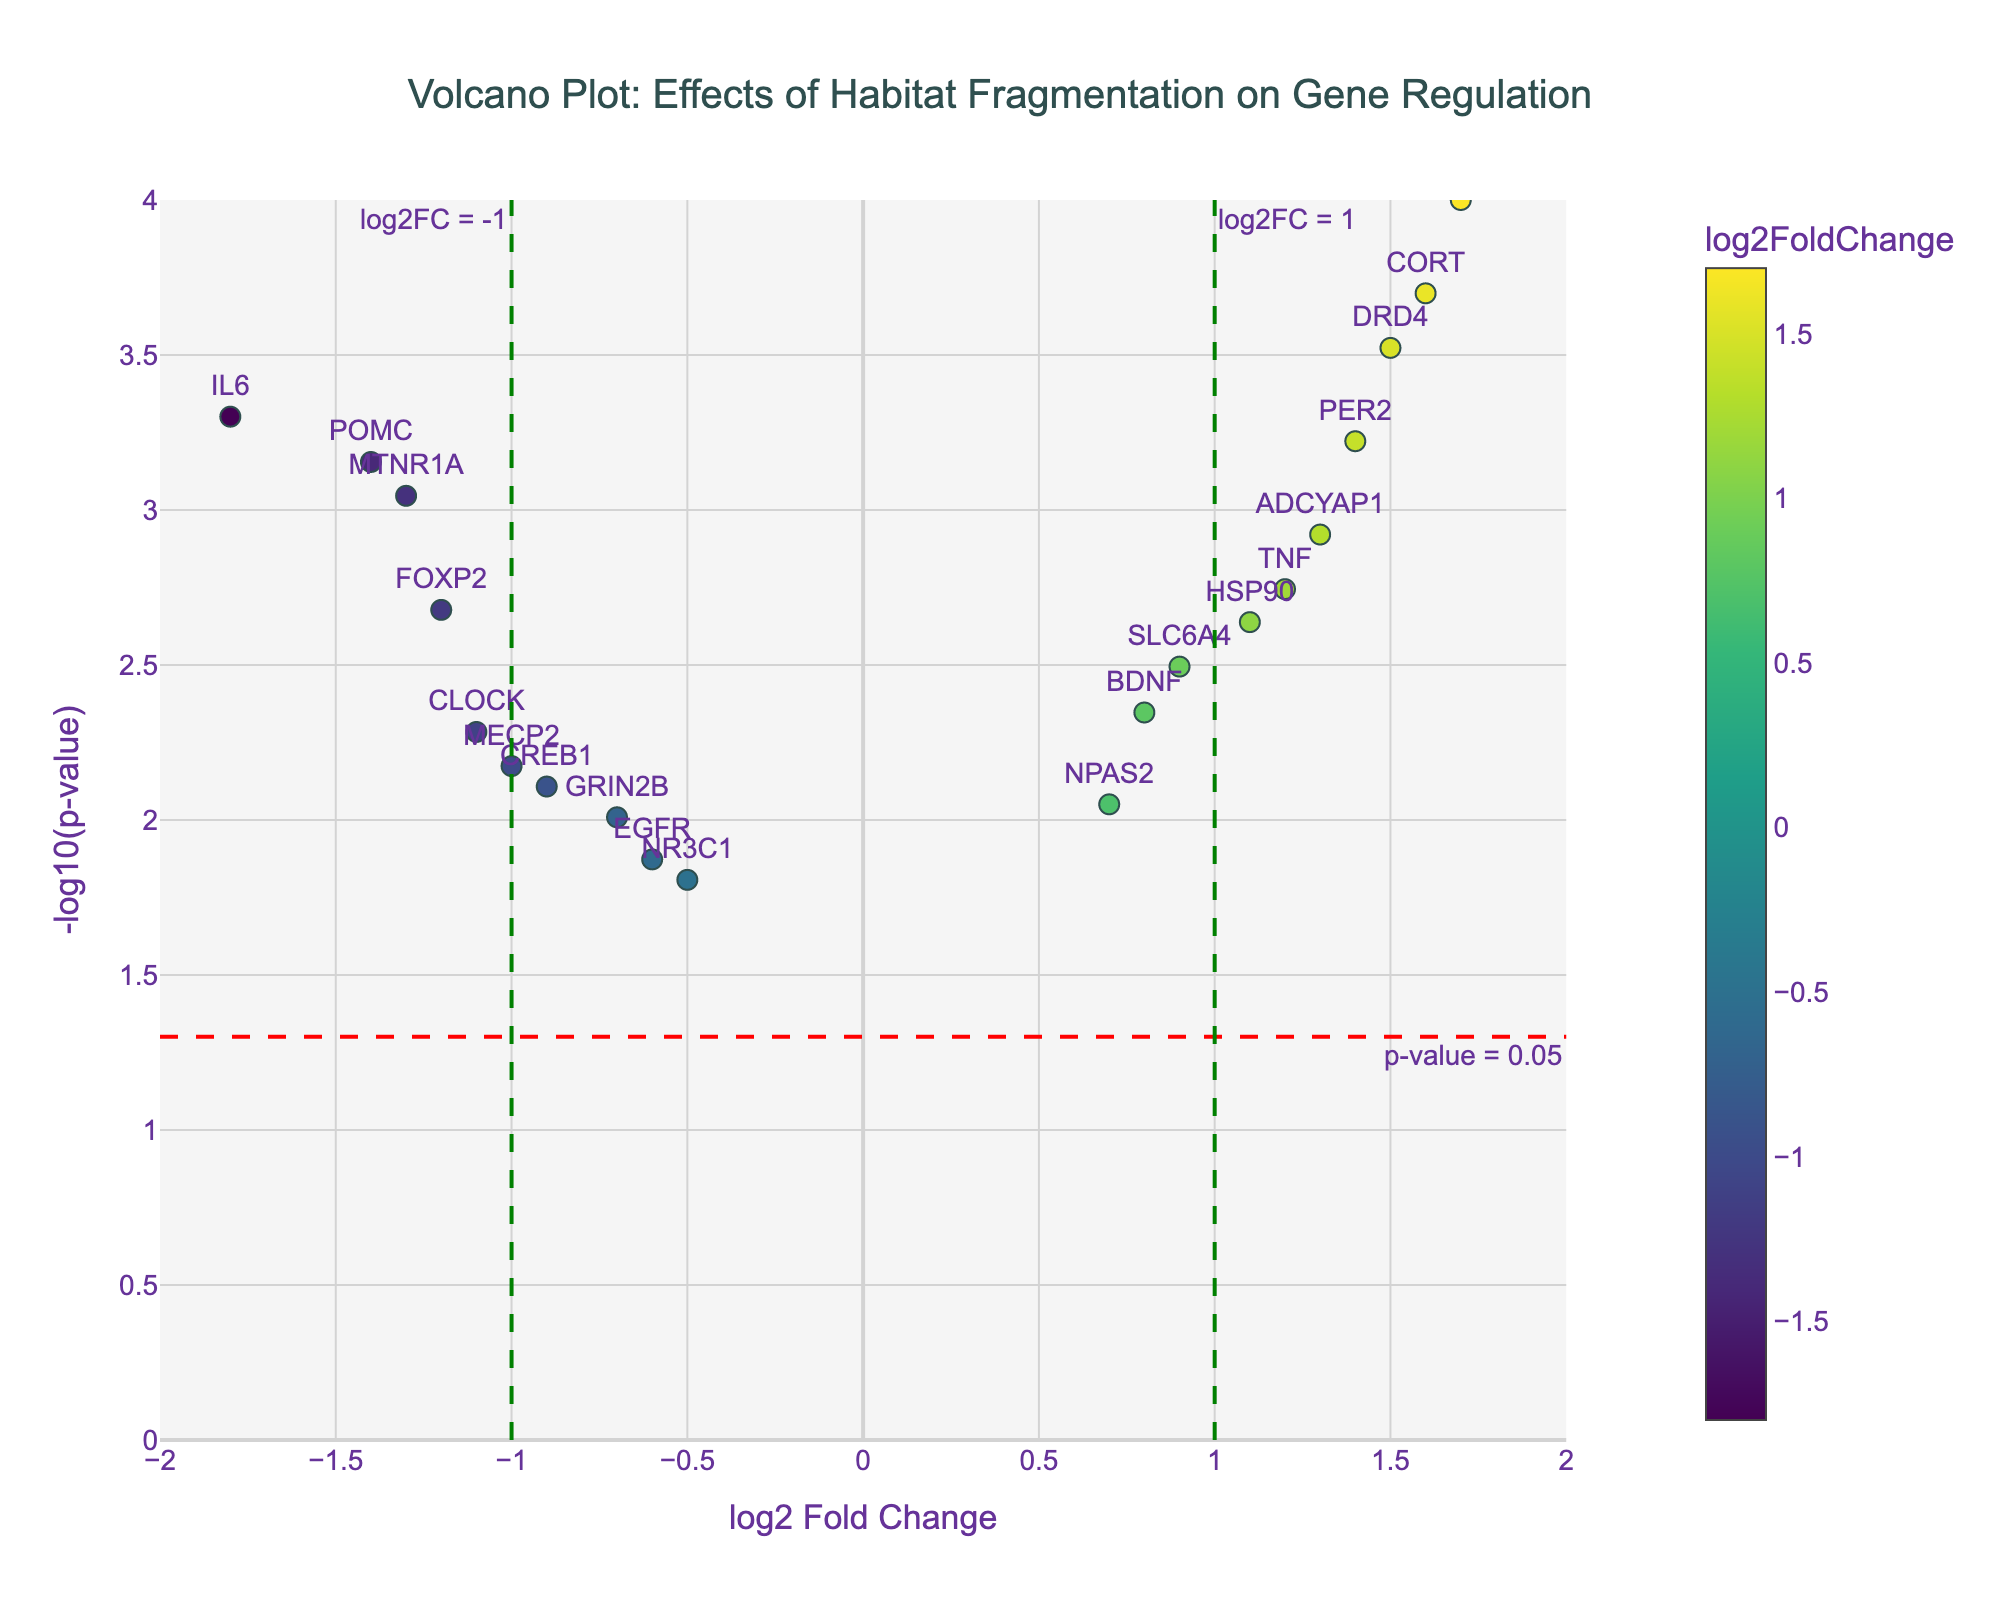What's the title of the plot? The title is located at the top center of the plot, and it summarizes the content of the entire figure.
Answer: Volcano Plot: Effects of Habitat Fragmentation on Gene Regulation What are the units on the y-axis? The y-axis title indicates the units used for measurement, which in this case is related to the p-value.
Answer: -log10(p-value) How many genes have a p-value less than 0.05? To determine this, identify the data points above the red threshold horizontal line, indicating a p-value less than 0.05. Count these points.
Answer: 18 Which gene has the highest log2 Fold Change? Identify the data point farthest to the right on the x-axis. This point represents the gene with the highest log2 Fold Change.
Answer: MMP9 Which gene has the lowest p-value? Identify the data point furthest up the y-axis. This point represents the gene with the lowest p-value.
Answer: MMP9 How many genes have a log2 Fold Change greater than 1? Count the data points located to the right of the green vertical dash line at log2FC = 1. These points represent genes with a log2 Fold Change greater than 1.
Answer: 5 Which genes have a log2 Fold Change less than -1 and a p-value below 0.05? Find the data points to the left of the green vertical line at log2FC = -1 and above the red horizontal line. These points represent genes with a log2 Fold Change less than -1 and a p-value below 0.05.
Answer: FOXP2, CLOCK, POMC, MTNR1A, IL6 Which gene has a log2 Fold Change close to zero but a very significant p-value? Identify the data point near zero on the x-axis and highest on the y-axis, indicating a non-significant fold change but a very significant p-value.
Answer: SLC6A4 Are there more genes with increased expression (positive log2 FC) or decreased expression (negative log2 FC)? Compare the number of data points to the left (negative log2FC) and the right (positive log2FC) of the zero line on the x-axis.
Answer: Increased expression (positive log2 FC) Which gene has an approximately equal but opposite log2 Fold Change value compared to FOXP2? Find the gene with a log2 Fold Change value that is roughly the positive equivalent of FOXP2's log2 Fold Change, which is -1.2.
Answer: TNF 